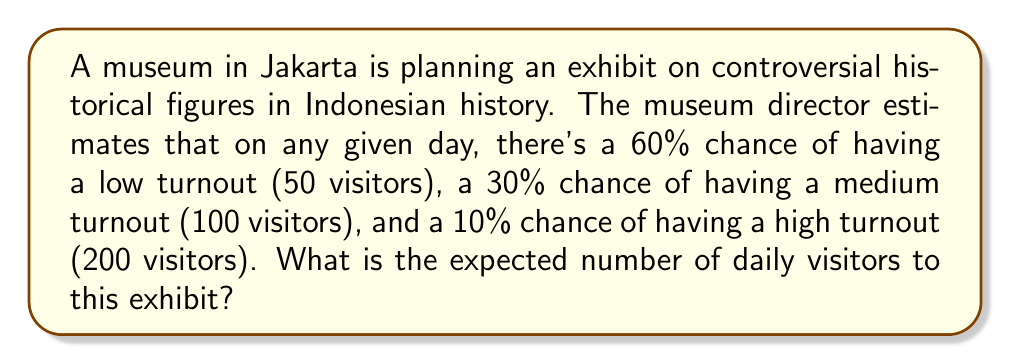Could you help me with this problem? Let's approach this step-by-step using the concept of expected value:

1) First, let's define our random variable X as the number of daily visitors.

2) We have three possible outcomes:
   - Low turnout: X = 50 with probability 0.60
   - Medium turnout: X = 100 with probability 0.30
   - High turnout: X = 200 with probability 0.10

3) The expected value formula is:

   $$E(X) = \sum_{i=1}^{n} x_i \cdot p(x_i)$$

   where $x_i$ are the possible values of X and $p(x_i)$ are their respective probabilities.

4) Plugging in our values:

   $$E(X) = 50 \cdot 0.60 + 100 \cdot 0.30 + 200 \cdot 0.10$$

5) Let's calculate each term:
   - $50 \cdot 0.60 = 30$
   - $100 \cdot 0.30 = 30$
   - $200 \cdot 0.10 = 20$

6) Sum these values:

   $$E(X) = 30 + 30 + 20 = 80$$

Therefore, the expected number of daily visitors is 80.
Answer: 80 visitors 